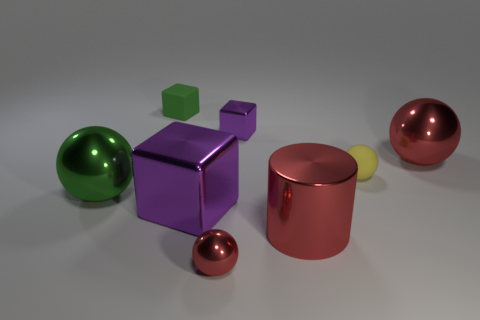Subtract all big red metallic spheres. How many spheres are left? 3 Subtract all yellow cylinders. How many red spheres are left? 2 Subtract all green spheres. How many spheres are left? 3 Subtract all yellow blocks. Subtract all yellow spheres. How many blocks are left? 3 Add 1 rubber objects. How many objects exist? 9 Subtract all cylinders. How many objects are left? 7 Add 1 tiny red things. How many tiny red things are left? 2 Add 1 large green balls. How many large green balls exist? 2 Subtract 0 brown blocks. How many objects are left? 8 Subtract all shiny cylinders. Subtract all green balls. How many objects are left? 6 